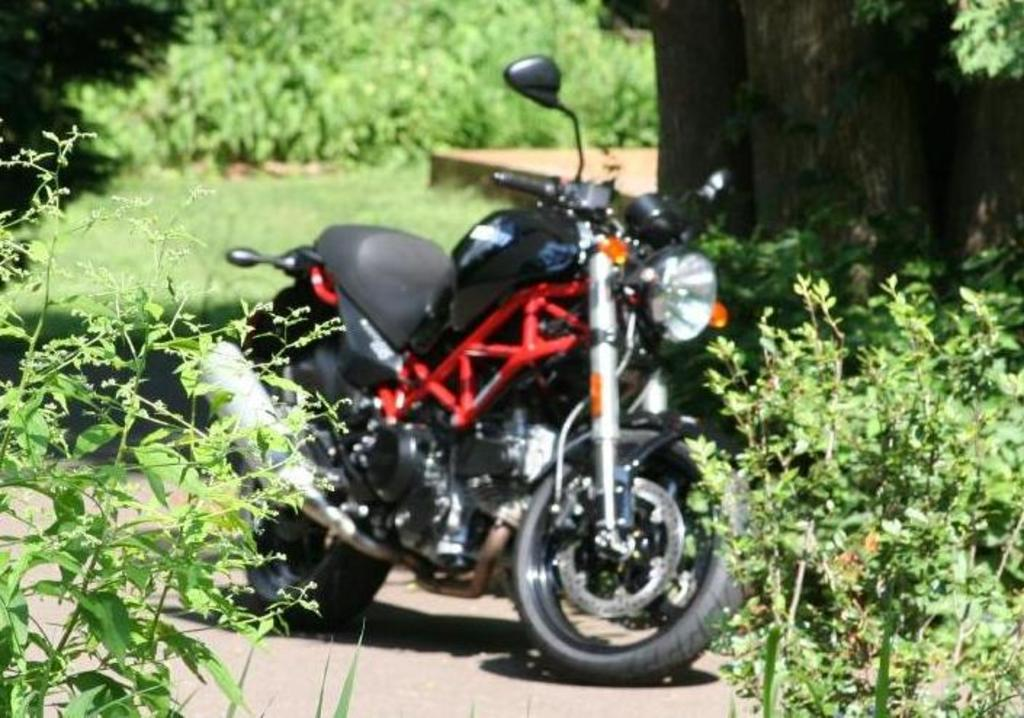What is the main subject of the image? The main subject of the image is a motorcycle. What can be seen beneath the motorcycle? The ground is visible in the image. What type of vegetation is present in the image? There are plants and grass in the image. What part of a tree can be seen in the image? Tree trunks are present in the image. Can you describe the unspecified object in the image? Unfortunately, the facts provided do not give enough information to describe the unspecified object. What type of music is the band playing in the image? There is no band present in the image, so it is not possible to determine what type of music might be played. 